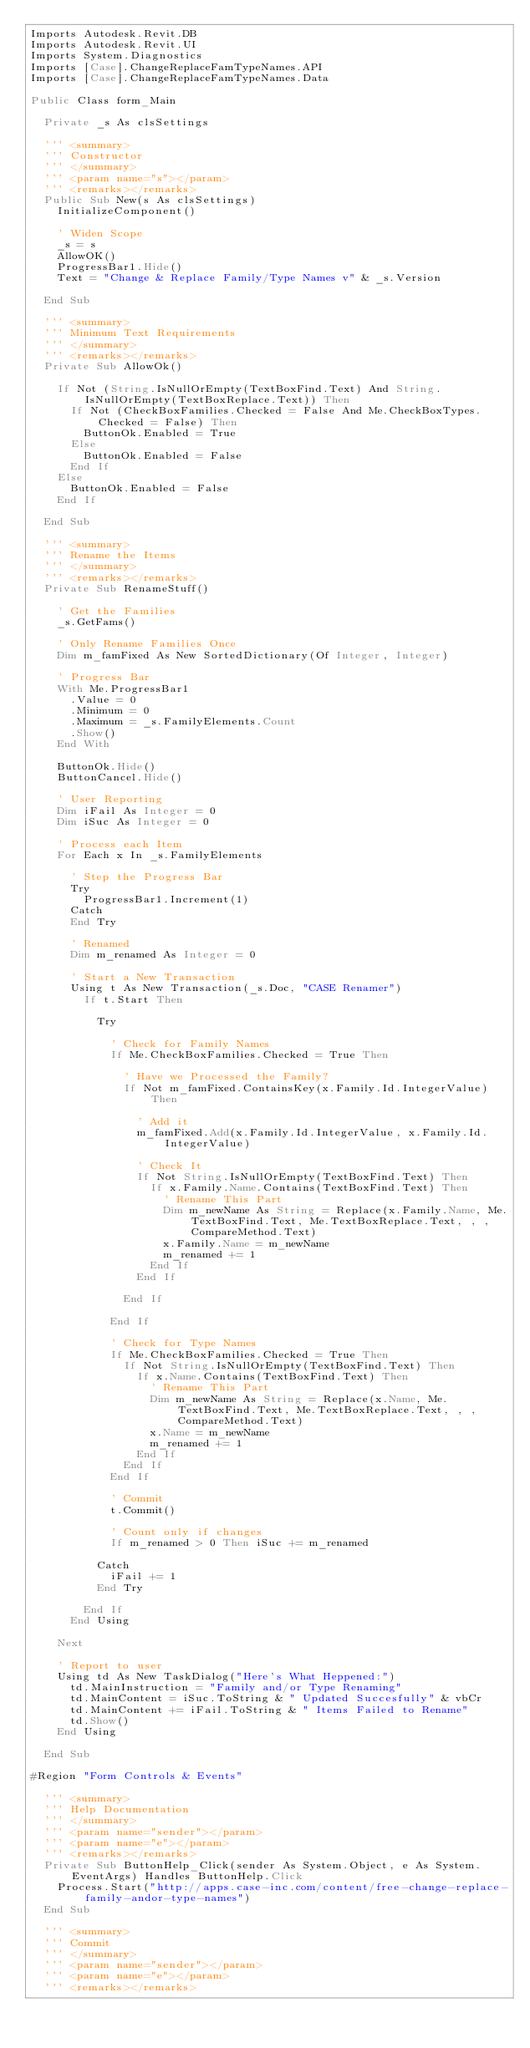Convert code to text. <code><loc_0><loc_0><loc_500><loc_500><_VisualBasic_>Imports Autodesk.Revit.DB
Imports Autodesk.Revit.UI
Imports System.Diagnostics
Imports [Case].ChangeReplaceFamTypeNames.API
Imports [Case].ChangeReplaceFamTypeNames.Data

Public Class form_Main

  Private _s As clsSettings

  ''' <summary>
  ''' Constructor
  ''' </summary>
  ''' <param name="s"></param>
  ''' <remarks></remarks>
  Public Sub New(s As clsSettings)
    InitializeComponent()

    ' Widen Scope
    _s = s
    AllowOK()
    ProgressBar1.Hide()
    Text = "Change & Replace Family/Type Names v" & _s.Version

  End Sub

  ''' <summary>
  ''' Minimum Text Requirements
  ''' </summary>
  ''' <remarks></remarks>
  Private Sub AllowOk()

    If Not (String.IsNullOrEmpty(TextBoxFind.Text) And String.IsNullOrEmpty(TextBoxReplace.Text)) Then
      If Not (CheckBoxFamilies.Checked = False And Me.CheckBoxTypes.Checked = False) Then
        ButtonOk.Enabled = True
      Else
        ButtonOk.Enabled = False
      End If
    Else
      ButtonOk.Enabled = False
    End If

  End Sub

  ''' <summary>
  ''' Rename the Items
  ''' </summary>
  ''' <remarks></remarks>
  Private Sub RenameStuff()

    ' Get the Families
    _s.GetFams()

    ' Only Rename Families Once
    Dim m_famFixed As New SortedDictionary(Of Integer, Integer)

    ' Progress Bar
    With Me.ProgressBar1
      .Value = 0
      .Minimum = 0
      .Maximum = _s.FamilyElements.Count
      .Show()
    End With

    ButtonOk.Hide()
    ButtonCancel.Hide()

    ' User Reporting
    Dim iFail As Integer = 0
    Dim iSuc As Integer = 0

    ' Process each Item
    For Each x In _s.FamilyElements

      ' Step the Progress Bar
      Try
        ProgressBar1.Increment(1)
      Catch
      End Try

      ' Renamed
      Dim m_renamed As Integer = 0

      ' Start a New Transaction
      Using t As New Transaction(_s.Doc, "CASE Renamer")
        If t.Start Then

          Try

            ' Check for Family Names
            If Me.CheckBoxFamilies.Checked = True Then

              ' Have we Processed the Family?
              If Not m_famFixed.ContainsKey(x.Family.Id.IntegerValue) Then

                ' Add it
                m_famFixed.Add(x.Family.Id.IntegerValue, x.Family.Id.IntegerValue)

                ' Check It
                If Not String.IsNullOrEmpty(TextBoxFind.Text) Then
                  If x.Family.Name.Contains(TextBoxFind.Text) Then
                    ' Rename This Part
                    Dim m_newName As String = Replace(x.Family.Name, Me.TextBoxFind.Text, Me.TextBoxReplace.Text, , , CompareMethod.Text)
                    x.Family.Name = m_newName
                    m_renamed += 1
                  End If
                End If

              End If

            End If

            ' Check for Type Names
            If Me.CheckBoxFamilies.Checked = True Then
              If Not String.IsNullOrEmpty(TextBoxFind.Text) Then
                If x.Name.Contains(TextBoxFind.Text) Then
                  ' Rename This Part
                  Dim m_newName As String = Replace(x.Name, Me.TextBoxFind.Text, Me.TextBoxReplace.Text, , , CompareMethod.Text)
                  x.Name = m_newName
                  m_renamed += 1
                End If
              End If
            End If

            ' Commit
            t.Commit()

            ' Count only if changes
            If m_renamed > 0 Then iSuc += m_renamed

          Catch
            iFail += 1
          End Try

        End If
      End Using

    Next

    ' Report to user
    Using td As New TaskDialog("Here's What Heppened:")
      td.MainInstruction = "Family and/or Type Renaming"
      td.MainContent = iSuc.ToString & " Updated Succesfully" & vbCr
      td.MainContent += iFail.ToString & " Items Failed to Rename"
      td.Show()
    End Using

  End Sub

#Region "Form Controls & Events"

  ''' <summary>
  ''' Help Documentation
  ''' </summary>
  ''' <param name="sender"></param>
  ''' <param name="e"></param>
  ''' <remarks></remarks>
  Private Sub ButtonHelp_Click(sender As System.Object, e As System.EventArgs) Handles ButtonHelp.Click
    Process.Start("http://apps.case-inc.com/content/free-change-replace-family-andor-type-names")
  End Sub

  ''' <summary>
  ''' Commit
  ''' </summary>
  ''' <param name="sender"></param>
  ''' <param name="e"></param>
  ''' <remarks></remarks></code> 